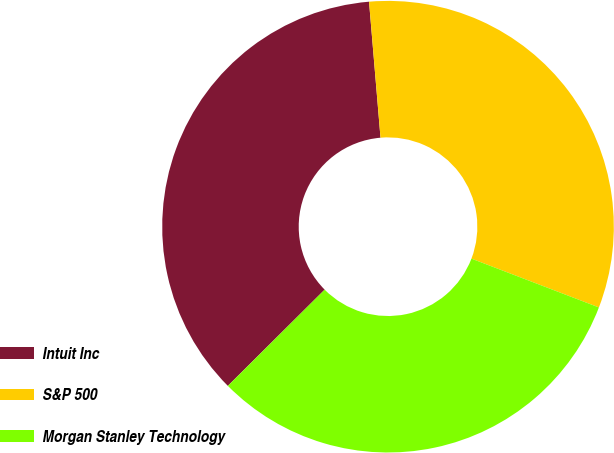<chart> <loc_0><loc_0><loc_500><loc_500><pie_chart><fcel>Intuit Inc<fcel>S&P 500<fcel>Morgan Stanley Technology<nl><fcel>36.11%<fcel>32.16%<fcel>31.73%<nl></chart> 